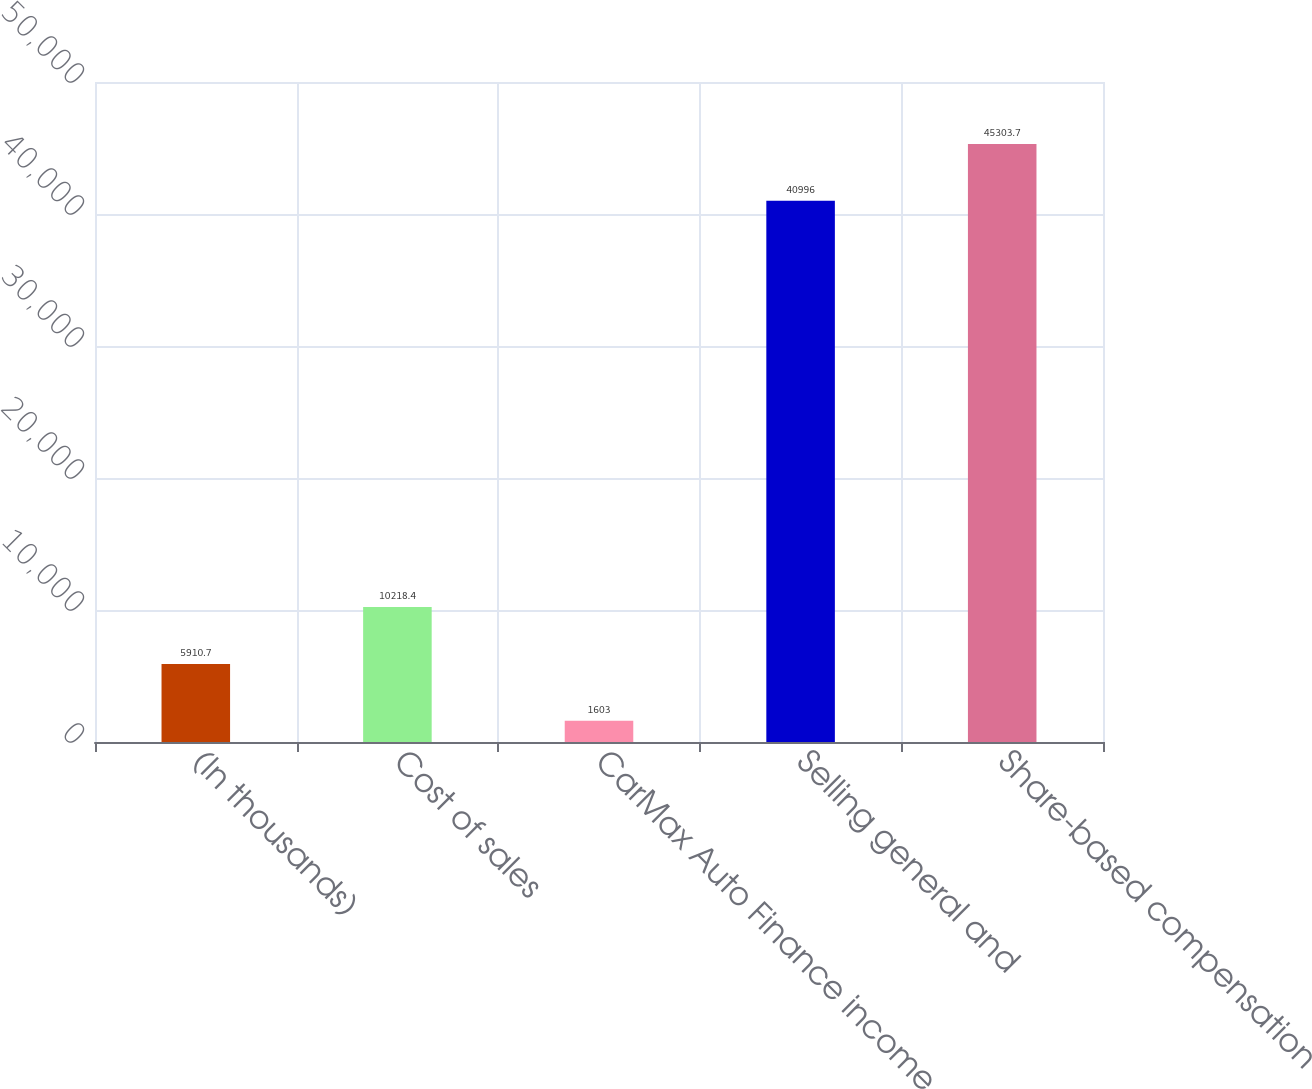<chart> <loc_0><loc_0><loc_500><loc_500><bar_chart><fcel>(In thousands)<fcel>Cost of sales<fcel>CarMax Auto Finance income<fcel>Selling general and<fcel>Share-based compensation<nl><fcel>5910.7<fcel>10218.4<fcel>1603<fcel>40996<fcel>45303.7<nl></chart> 